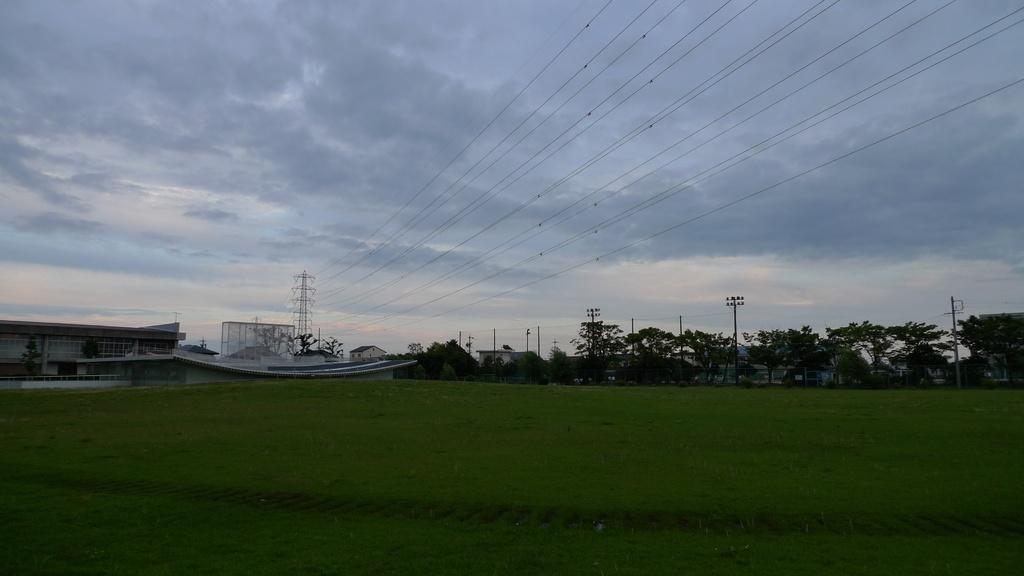What type of structures can be seen in the image? There are buildings in the image. What natural elements are present in the image? There are trees and grass visible in the image. What man-made objects can be seen in the image? There are poles and cables present in the image. What is visible at the top of the image? The sky is visible at the top of the image. What is visible at the bottom of the image? Grass is visible at the bottom of the image. Can you tell me where the lock is located in the image? There is no lock present in the image. What advice would your aunt give about the view in the image? There is no mention of an aunt or a view in the image, so it's not possible to answer that question. 